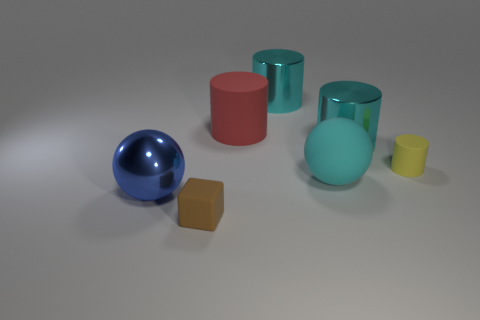How big is the yellow matte cylinder?
Give a very brief answer. Small. How many matte objects are to the right of the tiny thing that is in front of the large rubber object on the right side of the large red thing?
Ensure brevity in your answer.  3. There is a small matte object that is behind the large shiny object left of the small brown cube; what shape is it?
Ensure brevity in your answer.  Cylinder. There is another object that is the same shape as the large blue shiny thing; what is its size?
Your answer should be compact. Large. What is the color of the small object that is behind the blue metal ball?
Make the answer very short. Yellow. What is the material of the tiny cube that is to the left of the ball that is behind the metal object that is in front of the cyan sphere?
Give a very brief answer. Rubber. How big is the sphere left of the tiny matte thing in front of the yellow matte thing?
Ensure brevity in your answer.  Large. There is another large object that is the same shape as the blue shiny thing; what is its color?
Ensure brevity in your answer.  Cyan. How many metal things are the same color as the matte sphere?
Offer a terse response. 2. Is the size of the red thing the same as the yellow matte cylinder?
Provide a succinct answer. No. 